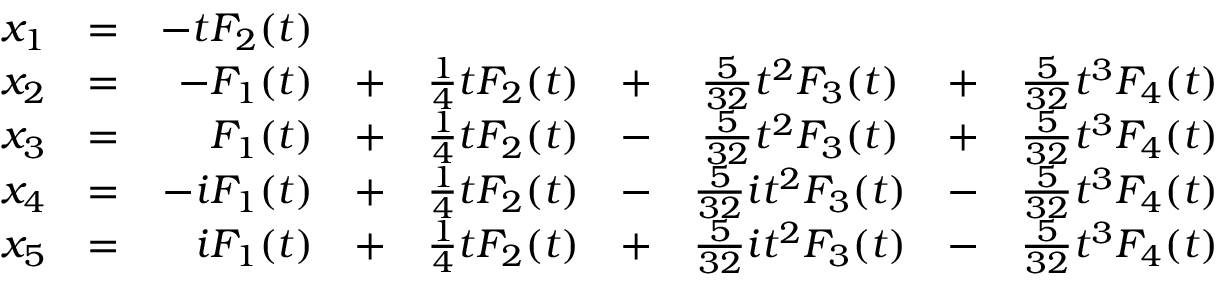Convert formula to latex. <formula><loc_0><loc_0><loc_500><loc_500>{ \begin{array} { r c r c c c c c c } { x _ { 1 } } & { = } & { - t F _ { 2 } ( t ) } \\ { x _ { 2 } } & { = } & { - F _ { 1 } ( t ) } & { + } & { { \frac { 1 } { 4 } } t F _ { 2 } ( t ) } & { + } & { { \frac { 5 } { 3 2 } } t ^ { 2 } F _ { 3 } ( t ) } & { + } & { { \frac { 5 } { 3 2 } } t ^ { 3 } F _ { 4 } ( t ) } \\ { x _ { 3 } } & { = } & { F _ { 1 } ( t ) } & { + } & { { \frac { 1 } { 4 } } t F _ { 2 } ( t ) } & { - } & { { \frac { 5 } { 3 2 } } t ^ { 2 } F _ { 3 } ( t ) } & { + } & { { \frac { 5 } { 3 2 } } t ^ { 3 } F _ { 4 } ( t ) } \\ { x _ { 4 } } & { = } & { - i F _ { 1 } ( t ) } & { + } & { { \frac { 1 } { 4 } } t F _ { 2 } ( t ) } & { - } & { { \frac { 5 } { 3 2 } } i t ^ { 2 } F _ { 3 } ( t ) } & { - } & { { \frac { 5 } { 3 2 } } t ^ { 3 } F _ { 4 } ( t ) } \\ { x _ { 5 } } & { = } & { i F _ { 1 } ( t ) } & { + } & { { \frac { 1 } { 4 } } t F _ { 2 } ( t ) } & { + } & { { \frac { 5 } { 3 2 } } i t ^ { 2 } F _ { 3 } ( t ) } & { - } & { { \frac { 5 } { 3 2 } } t ^ { 3 } F _ { 4 } ( t ) } \end{array} }</formula> 